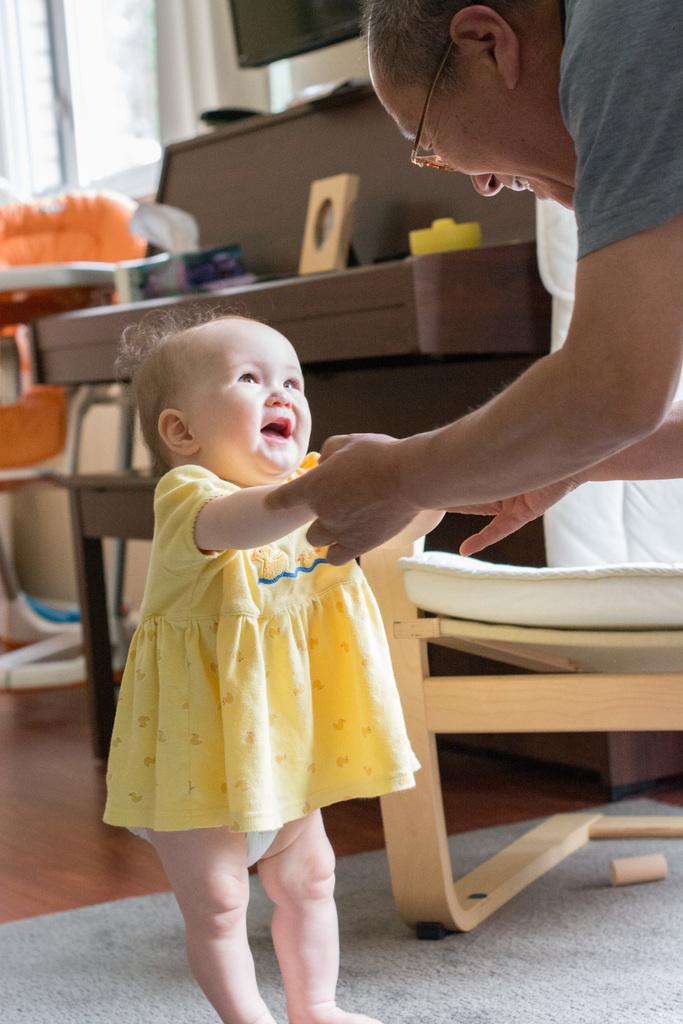What is the man in the image doing? The man is holding a baby in the image. Can you describe the man's appearance? The man is wearing spectacles in the image. What furniture is present in the image? There is a chair and a table in the image. What type of surface is the man and baby standing on? There is a floor in the image. What can be seen through the window in the image? The contents of the room beyond the window are not visible in the image. How many children are playing with wax on the sidewalk in the image? There are no children or wax present on a sidewalk in the image. 